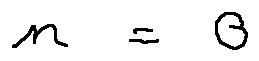<formula> <loc_0><loc_0><loc_500><loc_500>n = 0</formula> 